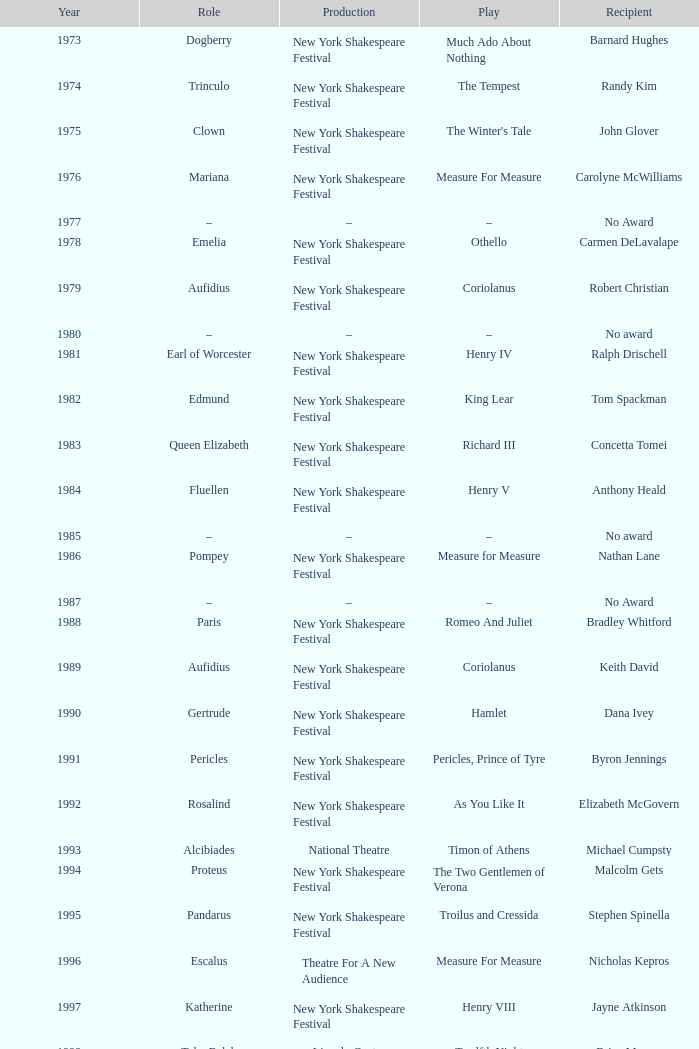Name the recipient of much ado about nothing for 1973 Barnard Hughes. 